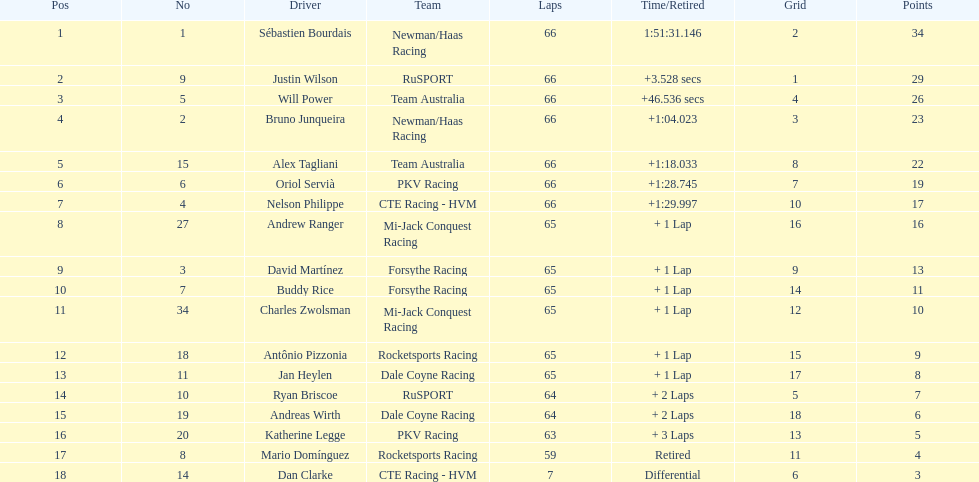At the 2006 gran premio telmex, did oriol servia or katherine legge complete more laps? Oriol Servià. 